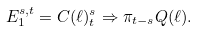<formula> <loc_0><loc_0><loc_500><loc_500>E _ { 1 } ^ { s , t } = C ( \ell ) _ { t } ^ { s } \Rightarrow \pi _ { t - s } Q ( \ell ) .</formula> 